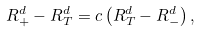Convert formula to latex. <formula><loc_0><loc_0><loc_500><loc_500>R _ { + } ^ { d } - R _ { T } ^ { d } = c \left ( { R _ { T } ^ { d } - R _ { - } ^ { d } } \right ) ,</formula> 